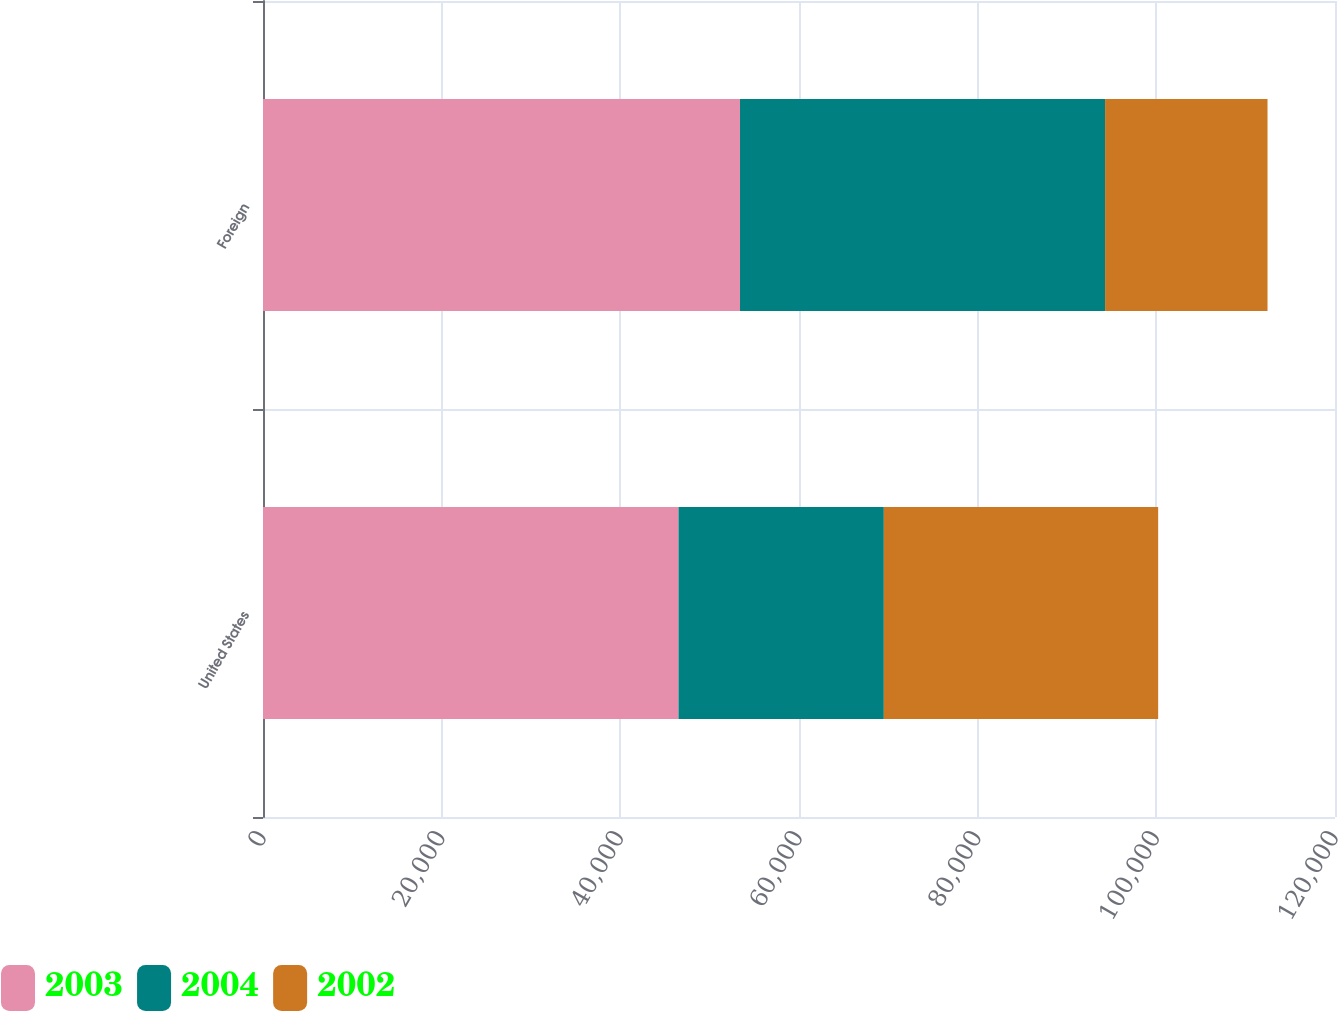<chart> <loc_0><loc_0><loc_500><loc_500><stacked_bar_chart><ecel><fcel>United States<fcel>Foreign<nl><fcel>2003<fcel>46512<fcel>53397<nl><fcel>2004<fcel>22984<fcel>40864<nl><fcel>2002<fcel>30708<fcel>18185<nl></chart> 